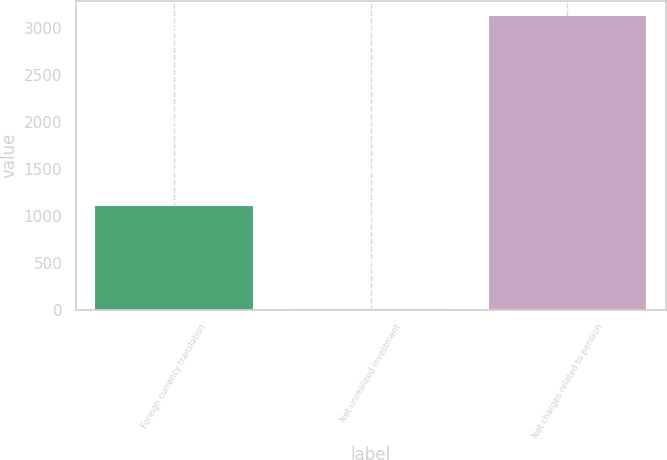Convert chart to OTSL. <chart><loc_0><loc_0><loc_500><loc_500><bar_chart><fcel>Foreign currency translation<fcel>Net unrealized investment<fcel>Net charges related to pension<nl><fcel>1102<fcel>6<fcel>3124<nl></chart> 